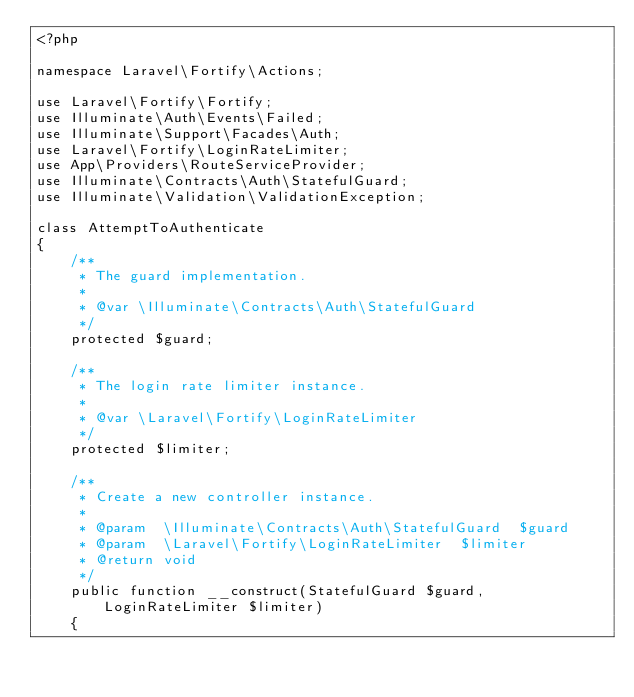Convert code to text. <code><loc_0><loc_0><loc_500><loc_500><_PHP_><?php

namespace Laravel\Fortify\Actions;

use Laravel\Fortify\Fortify;
use Illuminate\Auth\Events\Failed;
use Illuminate\Support\Facades\Auth;
use Laravel\Fortify\LoginRateLimiter;
use App\Providers\RouteServiceProvider;
use Illuminate\Contracts\Auth\StatefulGuard;
use Illuminate\Validation\ValidationException;

class AttemptToAuthenticate
{
    /**
     * The guard implementation.
     *
     * @var \Illuminate\Contracts\Auth\StatefulGuard
     */
    protected $guard;

    /**
     * The login rate limiter instance.
     *
     * @var \Laravel\Fortify\LoginRateLimiter
     */
    protected $limiter;

    /**
     * Create a new controller instance.
     *
     * @param  \Illuminate\Contracts\Auth\StatefulGuard  $guard
     * @param  \Laravel\Fortify\LoginRateLimiter  $limiter
     * @return void
     */
    public function __construct(StatefulGuard $guard, LoginRateLimiter $limiter)
    {</code> 